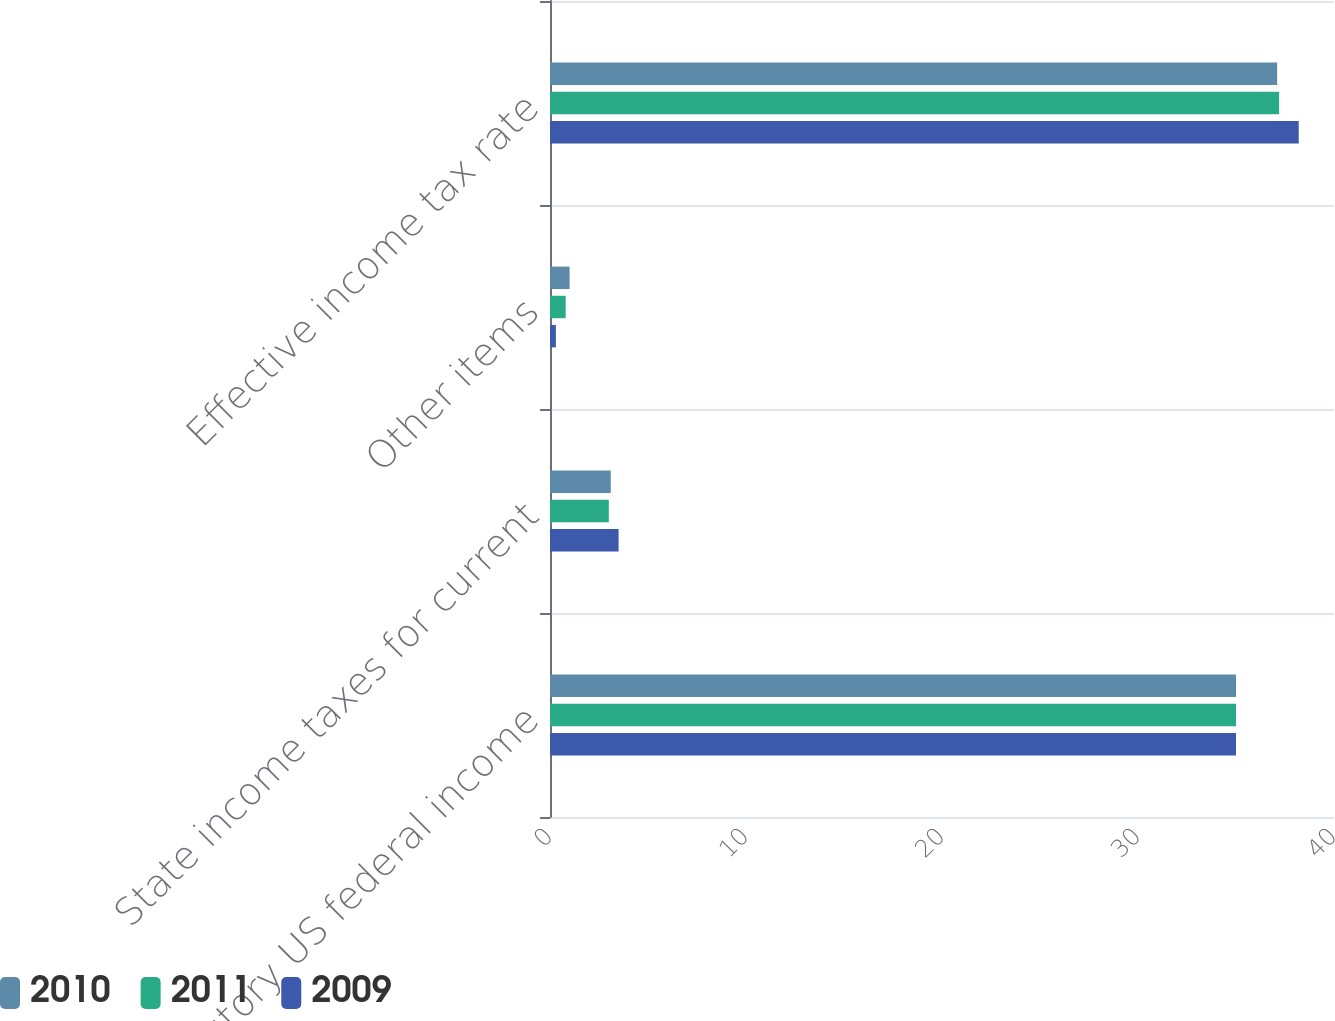Convert chart to OTSL. <chart><loc_0><loc_0><loc_500><loc_500><stacked_bar_chart><ecel><fcel>Statutory US federal income<fcel>State income taxes for current<fcel>Other items<fcel>Effective income tax rate<nl><fcel>2010<fcel>35<fcel>3.1<fcel>1<fcel>37.1<nl><fcel>2011<fcel>35<fcel>3<fcel>0.8<fcel>37.2<nl><fcel>2009<fcel>35<fcel>3.5<fcel>0.3<fcel>38.2<nl></chart> 